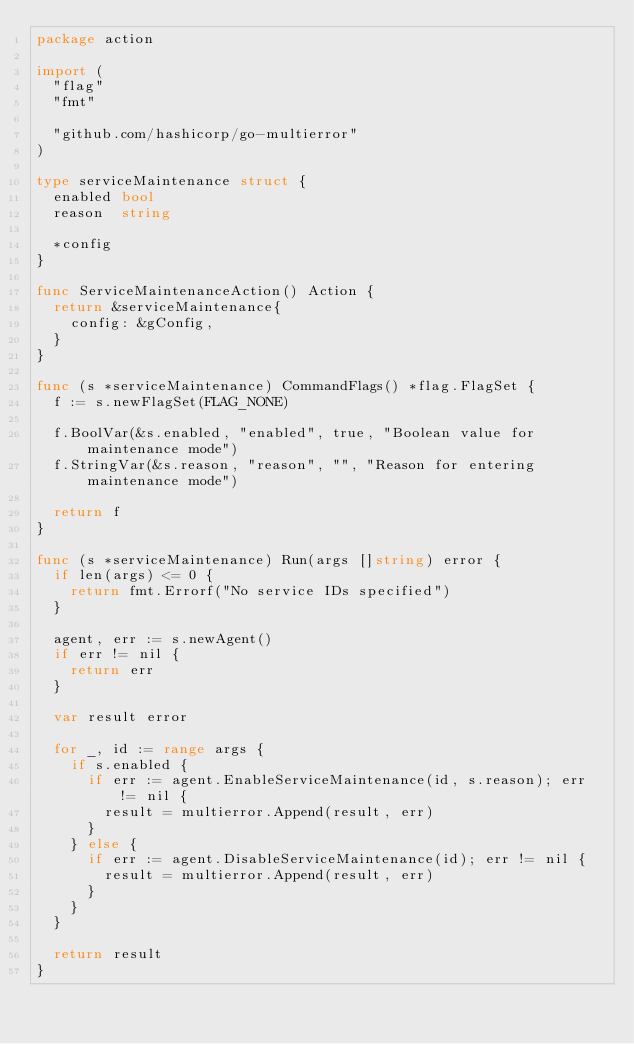Convert code to text. <code><loc_0><loc_0><loc_500><loc_500><_Go_>package action

import (
	"flag"
	"fmt"

	"github.com/hashicorp/go-multierror"
)

type serviceMaintenance struct {
	enabled bool
	reason  string

	*config
}

func ServiceMaintenanceAction() Action {
	return &serviceMaintenance{
		config: &gConfig,
	}
}

func (s *serviceMaintenance) CommandFlags() *flag.FlagSet {
	f := s.newFlagSet(FLAG_NONE)

	f.BoolVar(&s.enabled, "enabled", true, "Boolean value for maintenance mode")
	f.StringVar(&s.reason, "reason", "", "Reason for entering maintenance mode")

	return f
}

func (s *serviceMaintenance) Run(args []string) error {
	if len(args) <= 0 {
		return fmt.Errorf("No service IDs specified")
	}

	agent, err := s.newAgent()
	if err != nil {
		return err
	}

	var result error

	for _, id := range args {
		if s.enabled {
			if err := agent.EnableServiceMaintenance(id, s.reason); err != nil {
				result = multierror.Append(result, err)
			}
		} else {
			if err := agent.DisableServiceMaintenance(id); err != nil {
				result = multierror.Append(result, err)
			}
		}
	}

	return result
}
</code> 